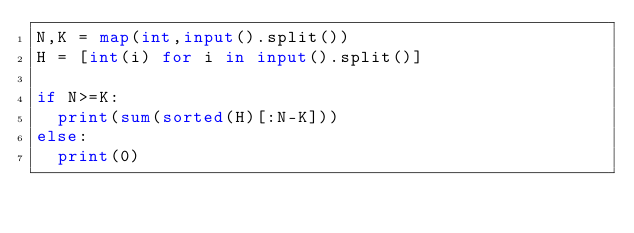<code> <loc_0><loc_0><loc_500><loc_500><_Python_>N,K = map(int,input().split())
H = [int(i) for i in input().split()]

if N>=K:
  print(sum(sorted(H)[:N-K]))
else:
  print(0)</code> 